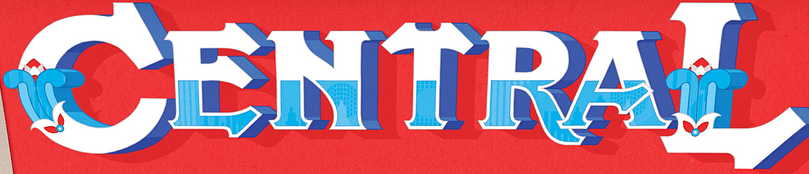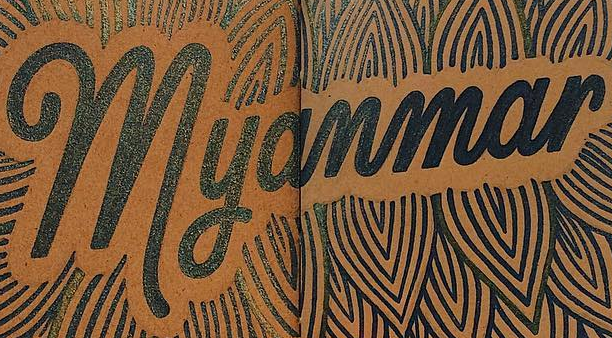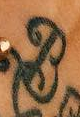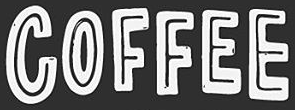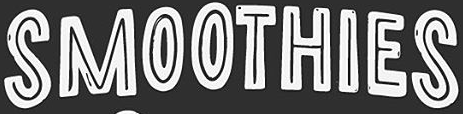What text is displayed in these images sequentially, separated by a semicolon? CENTRAL; Myanmar; B; COFFEE; SMOOTHIES 